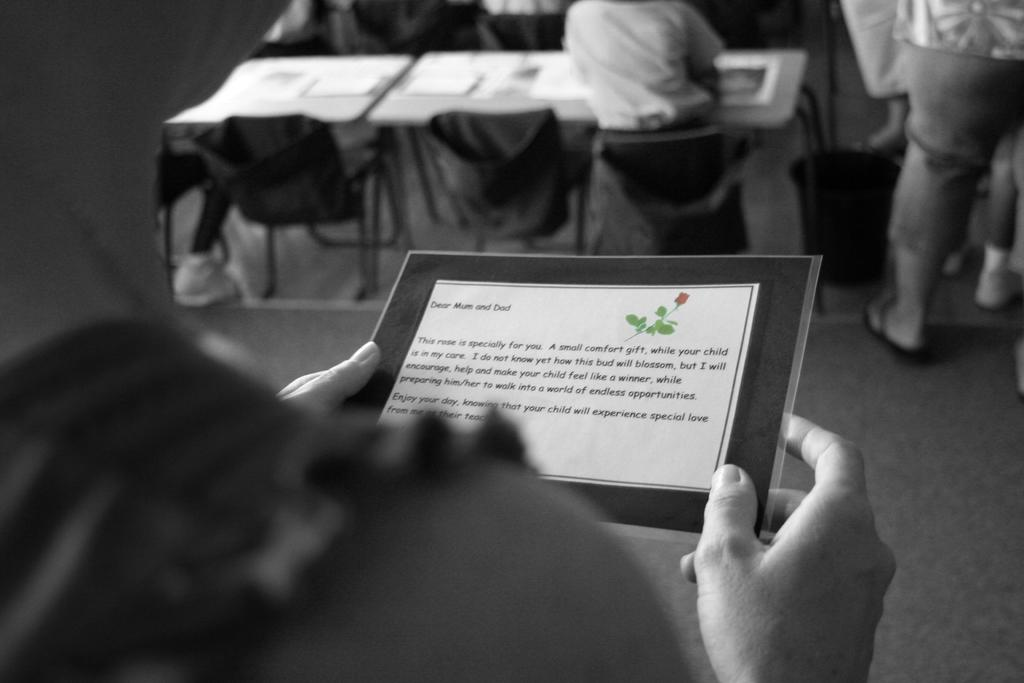What is the person holding in the image? There is a person holding a paper in the image. What piece of furniture is present in the image? There is a table in the image. What type of seating is available in the image? There are chairs in the image. What is the position of one of the persons in the image? There is a person sitting on a chair in the image. What is the posture of another person in the image? There is a person standing in the image. What type of toy can be seen on the table in the image? There is no toy present on the table in the image. What part of the brain is visible in the image? There is no part of the brain visible in the image. 